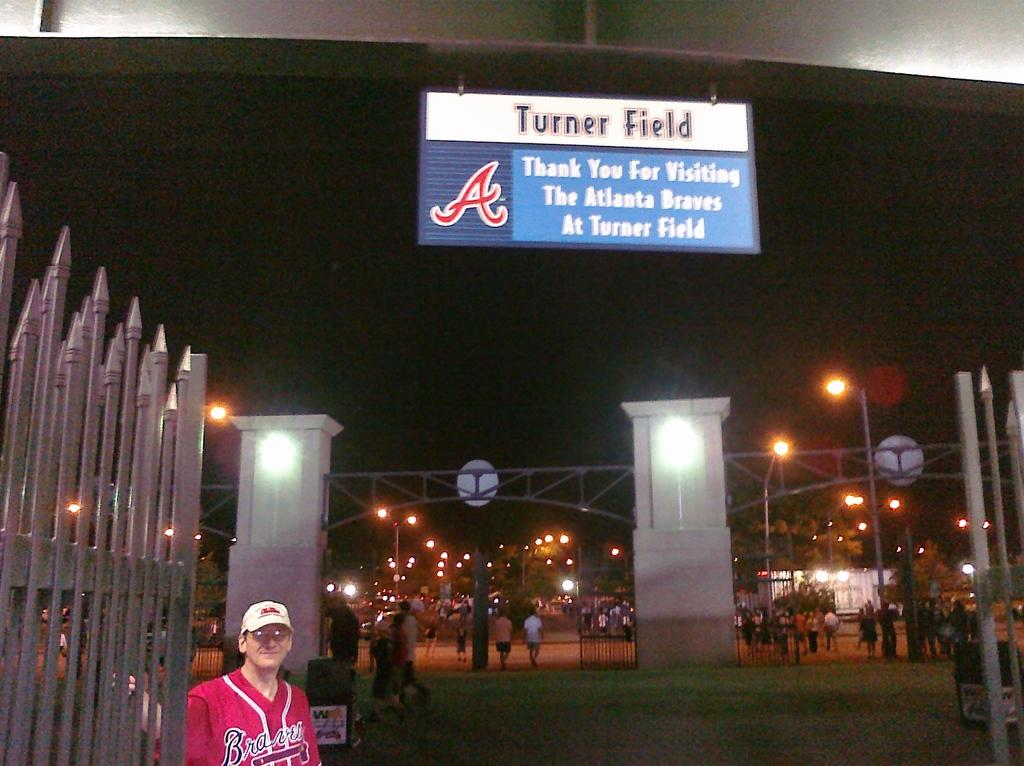<image>
Create a compact narrative representing the image presented. Man taking a picture under a sign that says Turner Field. 